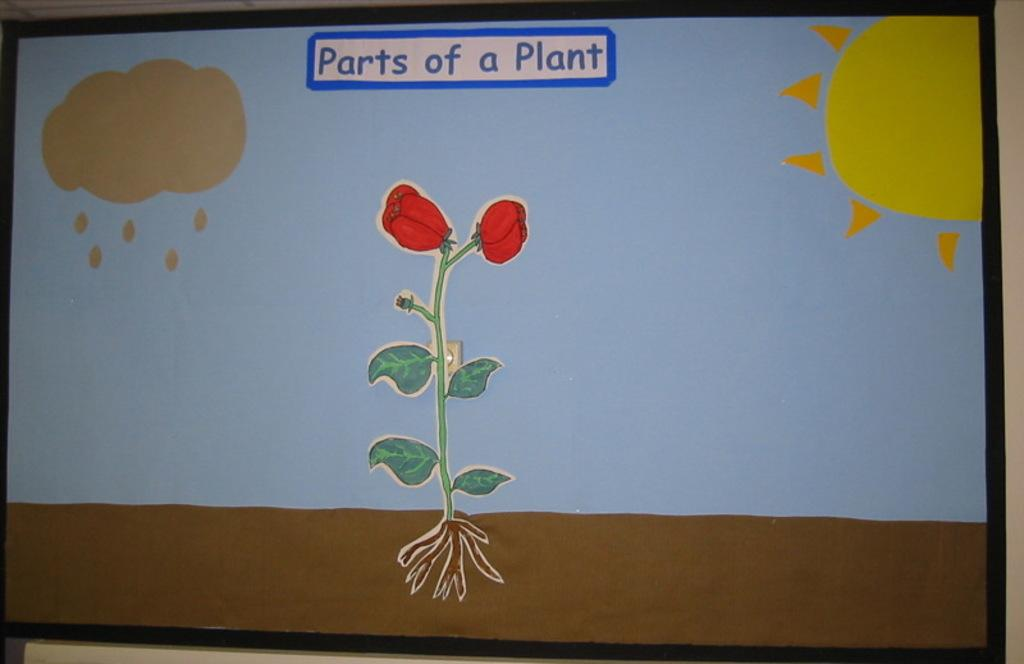What is the main subject of the image? The main subject of the image is a drawing. Can you describe the drawing in the image? The drawing has text on it. What type of animal can be seen learning to turn in the image? There is no animal or learning activity present in the image; it features a drawing with text. 